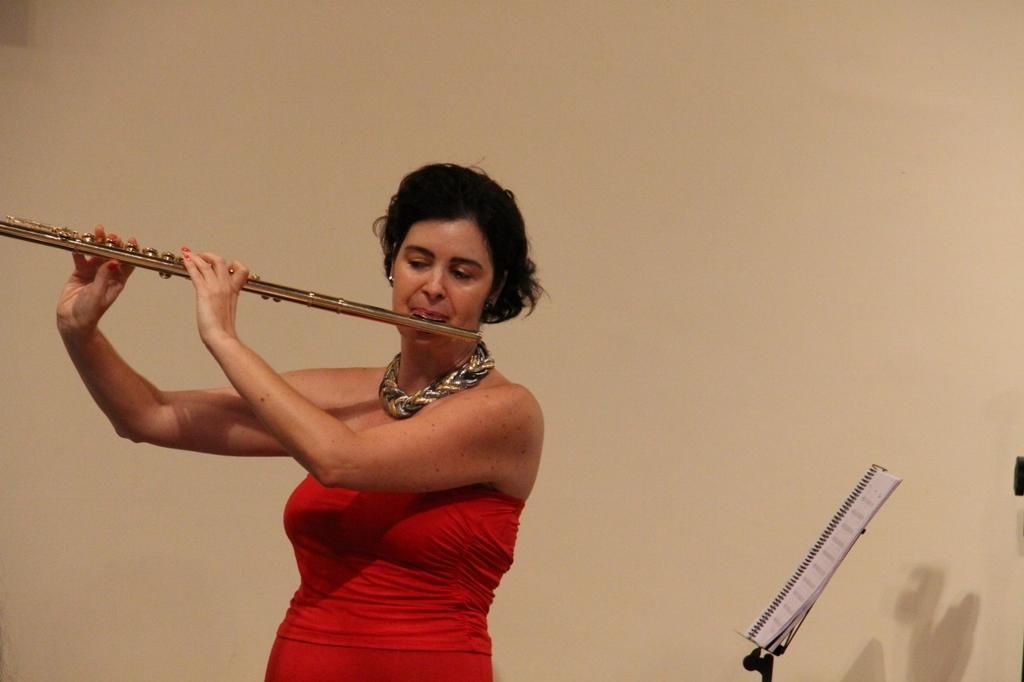How would you summarize this image in a sentence or two? In the background we can see the wall. In this picture we can see a woman wearing a necklace, red dress and she is holding a musical instrument in her hands and playing. On the right side of the picture we can see a spiral book on a stand. 